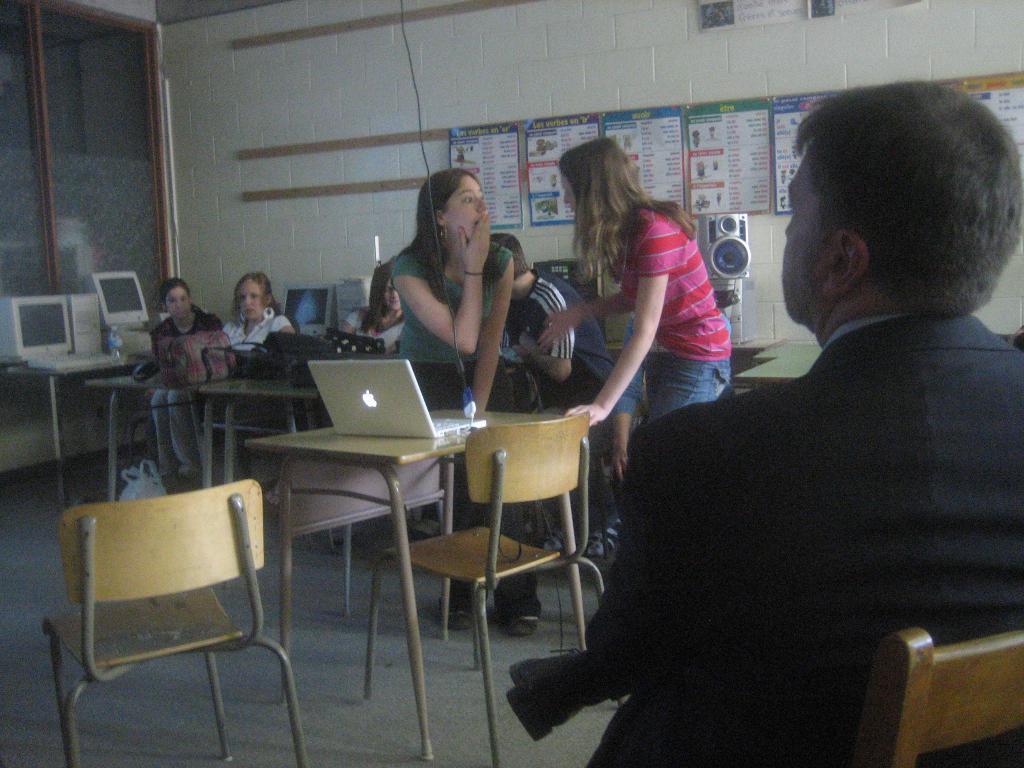In one or two sentences, can you explain what this image depicts? There is a person sitting on a chair and he is on the right side. Here we can see two woman who are standing in the center and they are having a conversation. There is a two people sitting on a chair. 